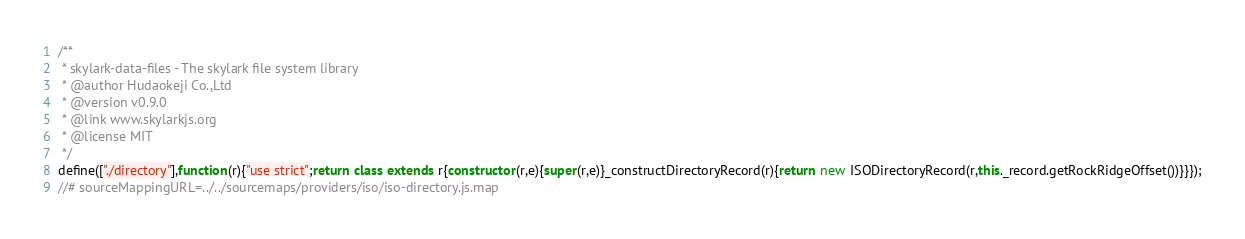Convert code to text. <code><loc_0><loc_0><loc_500><loc_500><_JavaScript_>/**
 * skylark-data-files - The skylark file system library
 * @author Hudaokeji Co.,Ltd
 * @version v0.9.0
 * @link www.skylarkjs.org
 * @license MIT
 */
define(["./directory"],function(r){"use strict";return class extends r{constructor(r,e){super(r,e)}_constructDirectoryRecord(r){return new ISODirectoryRecord(r,this._record.getRockRidgeOffset())}}});
//# sourceMappingURL=../../sourcemaps/providers/iso/iso-directory.js.map
</code> 